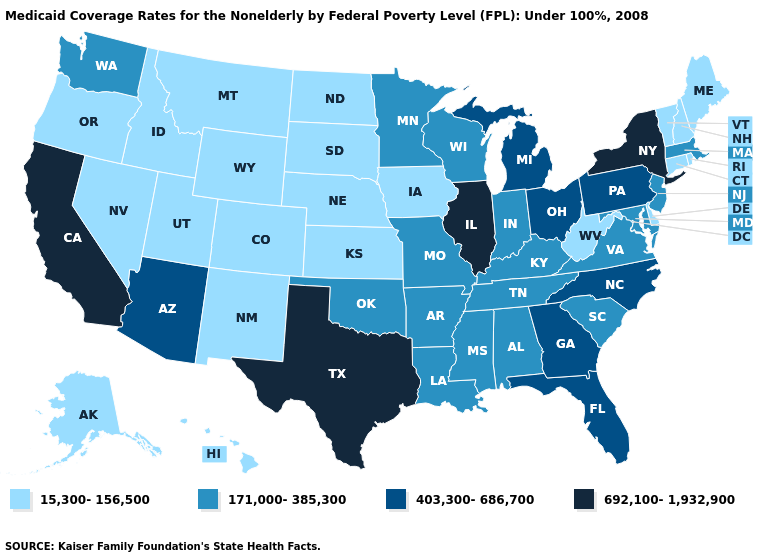Does the first symbol in the legend represent the smallest category?
Keep it brief. Yes. Does Montana have the same value as North Carolina?
Concise answer only. No. What is the highest value in the Northeast ?
Write a very short answer. 692,100-1,932,900. Name the states that have a value in the range 692,100-1,932,900?
Give a very brief answer. California, Illinois, New York, Texas. Does Nevada have the lowest value in the USA?
Be succinct. Yes. What is the value of Maine?
Quick response, please. 15,300-156,500. Among the states that border Missouri , which have the highest value?
Give a very brief answer. Illinois. Name the states that have a value in the range 692,100-1,932,900?
Concise answer only. California, Illinois, New York, Texas. What is the highest value in states that border Illinois?
Be succinct. 171,000-385,300. Does Wisconsin have the lowest value in the MidWest?
Give a very brief answer. No. Name the states that have a value in the range 692,100-1,932,900?
Quick response, please. California, Illinois, New York, Texas. Does the first symbol in the legend represent the smallest category?
Answer briefly. Yes. Which states have the lowest value in the MidWest?
Short answer required. Iowa, Kansas, Nebraska, North Dakota, South Dakota. Does Illinois have the highest value in the MidWest?
Give a very brief answer. Yes. What is the lowest value in the USA?
Quick response, please. 15,300-156,500. 